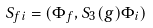Convert formula to latex. <formula><loc_0><loc_0><loc_500><loc_500>S _ { f i } = ( \Phi _ { f } , S _ { 3 } ( g ) \Phi _ { i } )</formula> 